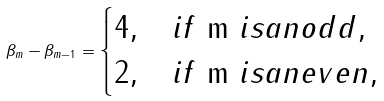Convert formula to latex. <formula><loc_0><loc_0><loc_500><loc_500>\beta _ { m } - \beta _ { m - 1 } = \begin{cases} 4 , & i f $ m $ i s a n o d d , \\ 2 , & i f $ m $ i s a n e v e n , \end{cases}</formula> 